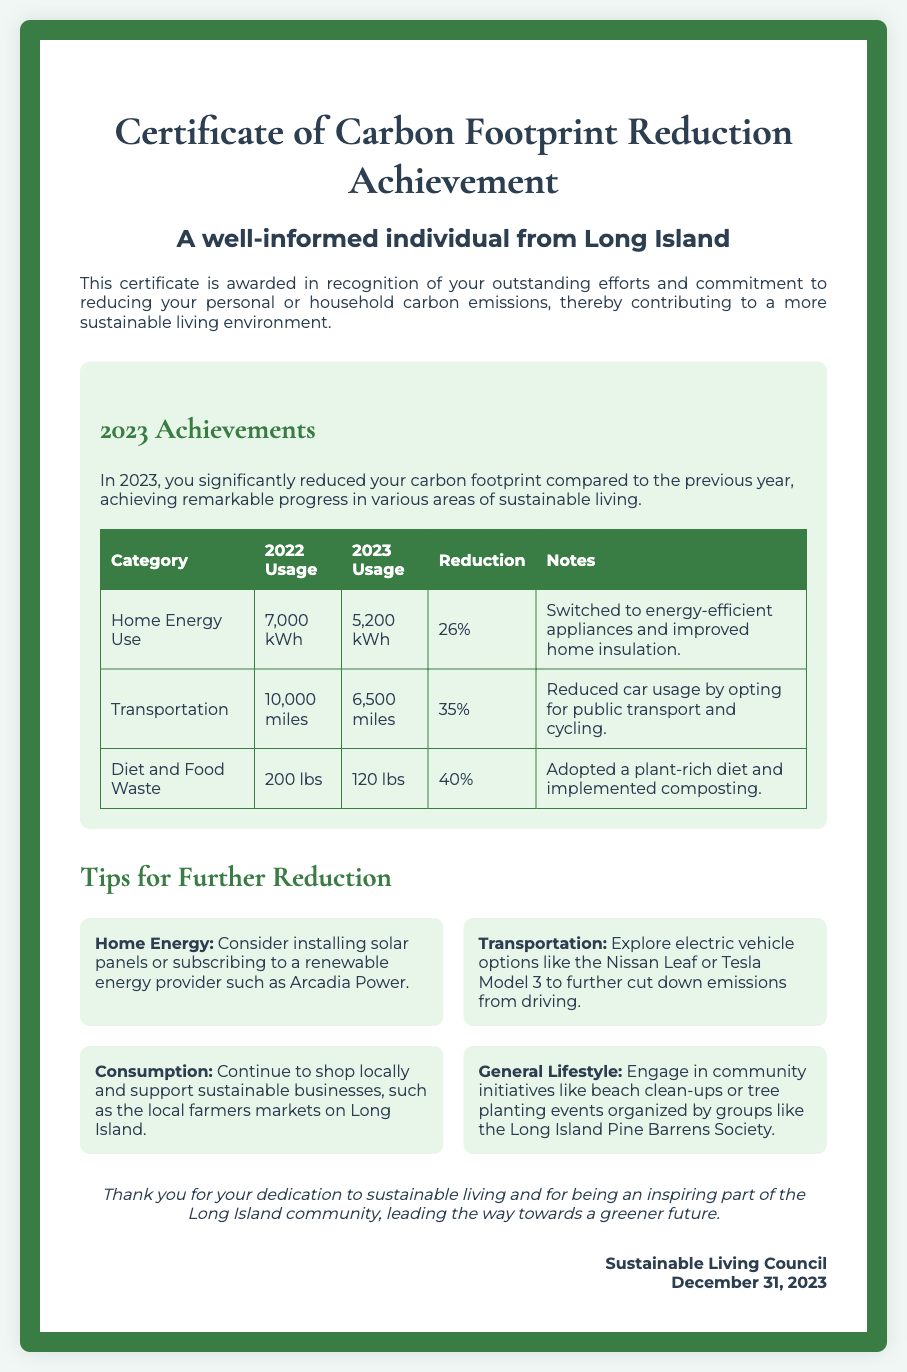What is the title of the document? The title of the document is prominently displayed at the top of the certificate.
Answer: Certificate of Carbon Footprint Reduction Achievement Who is the recipient of the certificate? The recipient's name is indicated in a specific section within the certificate.
Answer: A well-informed individual from Long Island What is the year of achievement recognized in the certificate? The year mentioned in the introduction indicates when the achievements occurred.
Answer: 2023 What was the Home Energy Use in 2022? The previous year's usage for Home Energy Use is provided in the table.
Answer: 7,000 kWh What percentage reduction was achieved in Transportation? The table shows the reduction percentage specific to the Transportation category.
Answer: 35% Which dietary change contributed to a 40% reduction in emissions? The notes in the table detail the contribution of dietary changes.
Answer: Adopted a plant-rich diet What is one suggested action to further reduce home energy consumption? The tips section provides actionable advice for continued reduction in home energy use.
Answer: Installing solar panels What community initiative is mentioned for further engagement? The tips section recommends community activities beneficial for the environment.
Answer: Beach clean-ups In what month and year was the certificate signed? The signature section outlines when the certificate was officially signed.
Answer: December 2023 